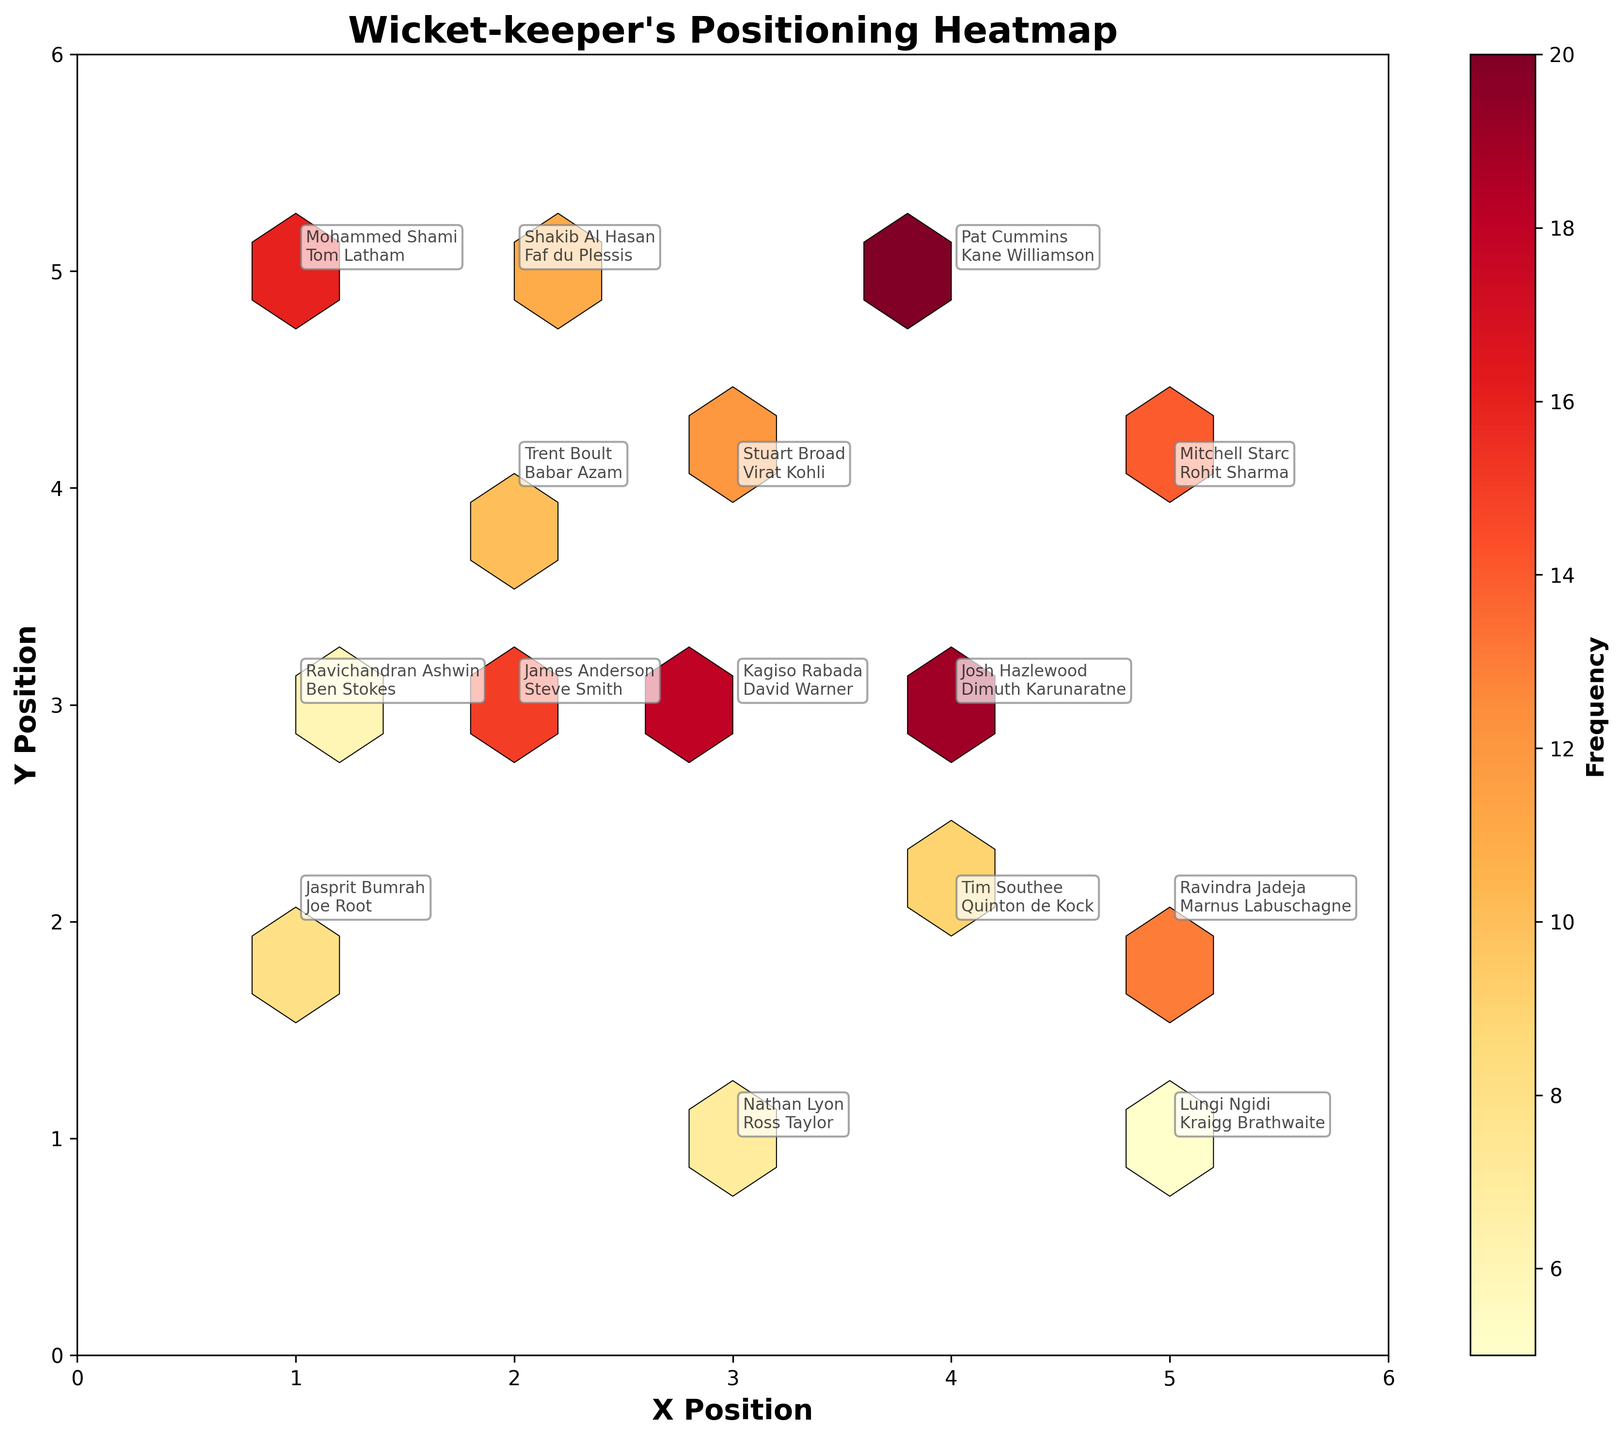what is the title of the figure? The title of the figure is displayed prominently at the top of the plot. It summarizes the subject of the plot.
Answer: Wicket-keeper's Positioning Heatmap what are the x and y axes representing? The x and y axes labels provide the meaning of the data points plotted along each axis.
Answer: X Position and Y Position which bowler-batsman pair is associated with the highest frequency? To find the highest frequency, check the color intensity or the hexbin with the highest value, then look for the annotation nearby.
Answer: Pat Cummins-Kane Williamson how many bowlers have been analyzed in the plot? The number of unique bowlers can be counted by looking at the different bowler names annotated on the plot.
Answer: 15 which hexbin represents the position (3, 3)? Locate the hexbin positioned at coordinates (3, 3) and identify the annotation associated with it to find the bowler-batsman pair.
Answer: Kagiso Rabada-David Warner what is the range of frequencies indicated by the color bar? Examine the color bar legend on the side of the chart; it represents the range of frequency values.
Answer: 5 to 20 where is the wicket-keeper most frequently positioned when bowled by Josh Hazlewood to Dimuth Karunaratne? Locate the positioning point of Josh Hazlewood and Dimuth Karunaratne by looking at the annotated point.
Answer: (4, 3) which bowler has the least frequent positioning against a batsman, and what is their coordinate? Identify the bowler-batsman pair with the lowest frequency value by checking the color and the frequency value near each annotation.
Answer: Lungi Ngidi-Kraigg Brathwaite at (5, 1) between which x and y positions do most wicket-keepers stand? Illuminations of the densest areas on the hexbin plot indicate where most positioning occurs.
Answer: Between x=2-4 and y=3-5 which bowler(batsman) combination happens the most around the central point (3, 3)? Identify hexbin closest to (3, 3) with the highest frequency and annotate it to check the bowler and batsman.
Answer: Kagiso Rabada-David Warner 